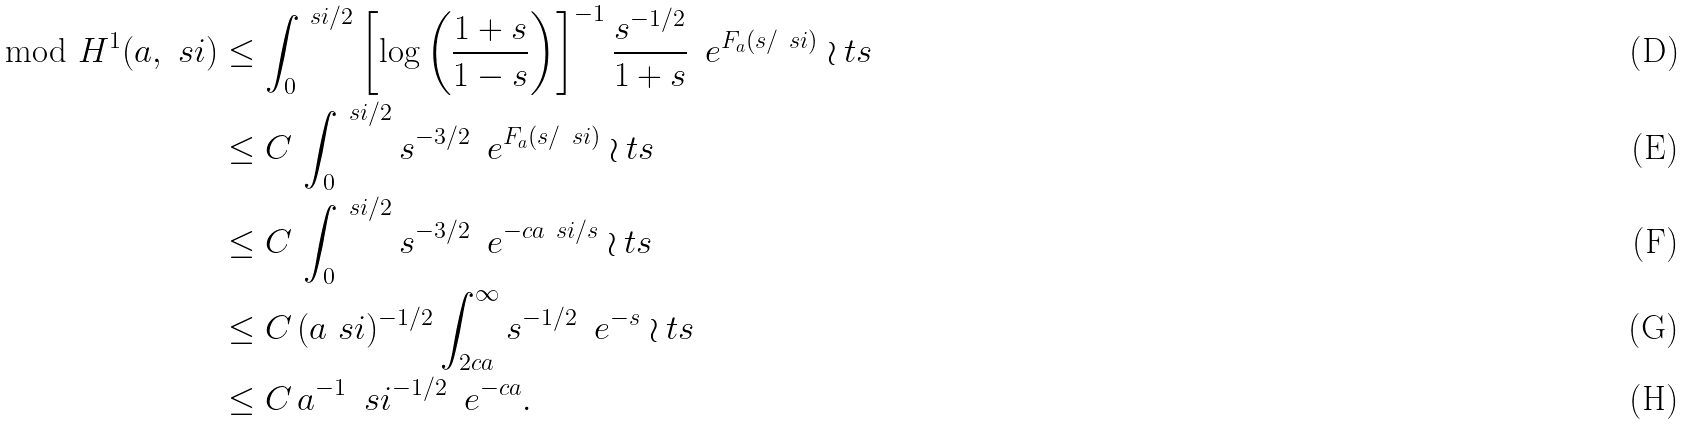<formula> <loc_0><loc_0><loc_500><loc_500>\mod { H ^ { 1 } ( a , \ s i ) } & \leq \int ^ { \ s i / 2 } _ { 0 } \left [ \log \left ( \frac { 1 + s } { 1 - s } \right ) \right ] ^ { - 1 } \frac { s ^ { - 1 / 2 } } { 1 + s } \, \ e ^ { F _ { a } ( s / \ s i ) } \wr t s \\ & \leq C \, \int ^ { \ s i / 2 } _ { 0 } s ^ { - 3 / 2 } \, \ e ^ { F _ { a } ( s / \ s i ) } \wr t s \\ & \leq C \, \int ^ { \ s i / 2 } _ { 0 } s ^ { - 3 / 2 } \, \ e ^ { - c a \ s i / s } \wr t s \\ & \leq C \, ( a \ s i ) ^ { - 1 / 2 } \int ^ { \infty } _ { 2 c a } s ^ { - 1 / 2 } \, \ e ^ { - s } \wr t s \\ & \leq C \, a ^ { - 1 } \, \ s i ^ { - 1 / 2 } \, \ e ^ { - c a } .</formula> 